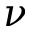<formula> <loc_0><loc_0><loc_500><loc_500>{ \nu }</formula> 